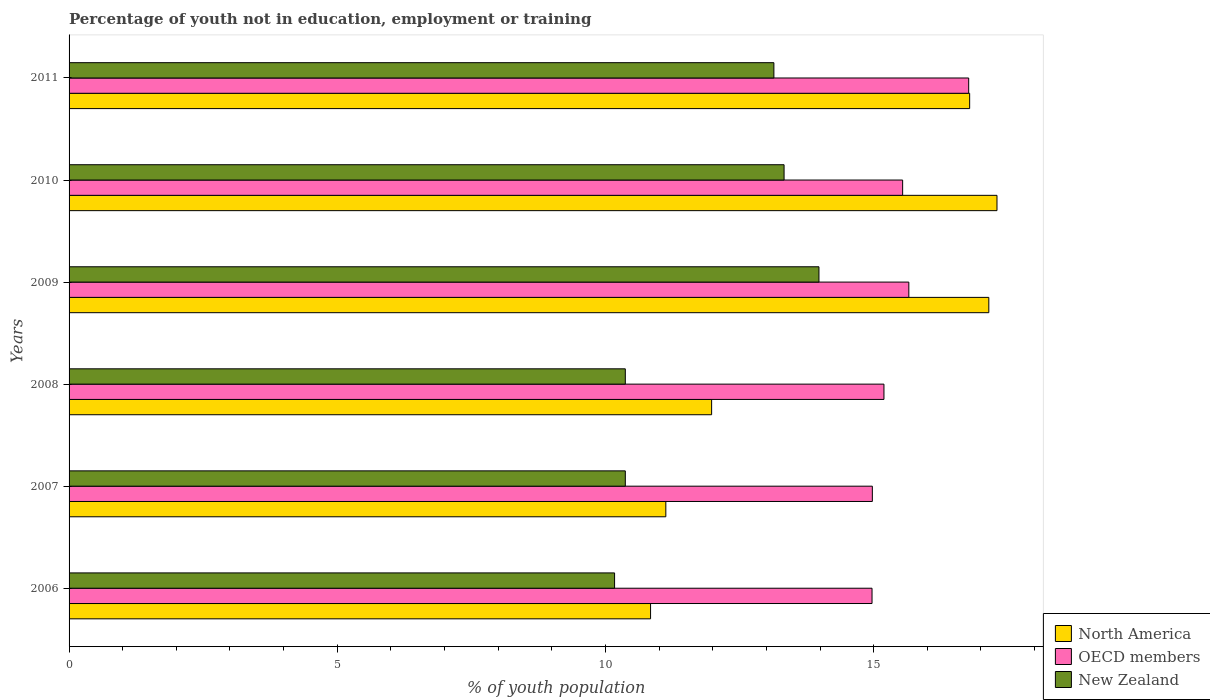How many groups of bars are there?
Give a very brief answer. 6. Are the number of bars on each tick of the Y-axis equal?
Provide a succinct answer. Yes. What is the label of the 2nd group of bars from the top?
Give a very brief answer. 2010. What is the percentage of unemployed youth population in in New Zealand in 2006?
Offer a very short reply. 10.17. Across all years, what is the maximum percentage of unemployed youth population in in North America?
Give a very brief answer. 17.3. Across all years, what is the minimum percentage of unemployed youth population in in New Zealand?
Ensure brevity in your answer.  10.17. What is the total percentage of unemployed youth population in in New Zealand in the graph?
Provide a short and direct response. 71.36. What is the difference between the percentage of unemployed youth population in in North America in 2010 and that in 2011?
Keep it short and to the point. 0.51. What is the difference between the percentage of unemployed youth population in in North America in 2009 and the percentage of unemployed youth population in in New Zealand in 2008?
Offer a terse response. 6.78. What is the average percentage of unemployed youth population in in North America per year?
Keep it short and to the point. 14.2. In the year 2008, what is the difference between the percentage of unemployed youth population in in OECD members and percentage of unemployed youth population in in North America?
Provide a succinct answer. 3.21. What is the ratio of the percentage of unemployed youth population in in OECD members in 2007 to that in 2010?
Your answer should be very brief. 0.96. Is the percentage of unemployed youth population in in OECD members in 2006 less than that in 2008?
Your answer should be very brief. Yes. Is the difference between the percentage of unemployed youth population in in OECD members in 2006 and 2010 greater than the difference between the percentage of unemployed youth population in in North America in 2006 and 2010?
Your answer should be very brief. Yes. What is the difference between the highest and the second highest percentage of unemployed youth population in in North America?
Make the answer very short. 0.15. What is the difference between the highest and the lowest percentage of unemployed youth population in in North America?
Ensure brevity in your answer.  6.46. Is the sum of the percentage of unemployed youth population in in New Zealand in 2006 and 2009 greater than the maximum percentage of unemployed youth population in in OECD members across all years?
Your response must be concise. Yes. What does the 1st bar from the top in 2006 represents?
Give a very brief answer. New Zealand. What does the 3rd bar from the bottom in 2008 represents?
Keep it short and to the point. New Zealand. Is it the case that in every year, the sum of the percentage of unemployed youth population in in North America and percentage of unemployed youth population in in OECD members is greater than the percentage of unemployed youth population in in New Zealand?
Provide a succinct answer. Yes. How many bars are there?
Make the answer very short. 18. How many years are there in the graph?
Your response must be concise. 6. Does the graph contain any zero values?
Your answer should be very brief. No. Where does the legend appear in the graph?
Keep it short and to the point. Bottom right. What is the title of the graph?
Provide a short and direct response. Percentage of youth not in education, employment or training. What is the label or title of the X-axis?
Your answer should be compact. % of youth population. What is the % of youth population in North America in 2006?
Ensure brevity in your answer.  10.84. What is the % of youth population in OECD members in 2006?
Give a very brief answer. 14.97. What is the % of youth population of New Zealand in 2006?
Offer a terse response. 10.17. What is the % of youth population in North America in 2007?
Provide a succinct answer. 11.13. What is the % of youth population in OECD members in 2007?
Your answer should be very brief. 14.98. What is the % of youth population in New Zealand in 2007?
Give a very brief answer. 10.37. What is the % of youth population in North America in 2008?
Provide a succinct answer. 11.98. What is the % of youth population of OECD members in 2008?
Your response must be concise. 15.19. What is the % of youth population in New Zealand in 2008?
Your response must be concise. 10.37. What is the % of youth population in North America in 2009?
Offer a very short reply. 17.15. What is the % of youth population of OECD members in 2009?
Your response must be concise. 15.66. What is the % of youth population in New Zealand in 2009?
Make the answer very short. 13.98. What is the % of youth population of North America in 2010?
Your response must be concise. 17.3. What is the % of youth population of OECD members in 2010?
Ensure brevity in your answer.  15.54. What is the % of youth population of New Zealand in 2010?
Give a very brief answer. 13.33. What is the % of youth population in North America in 2011?
Make the answer very short. 16.79. What is the % of youth population in OECD members in 2011?
Offer a terse response. 16.77. What is the % of youth population in New Zealand in 2011?
Offer a very short reply. 13.14. Across all years, what is the maximum % of youth population of North America?
Provide a short and direct response. 17.3. Across all years, what is the maximum % of youth population of OECD members?
Your answer should be compact. 16.77. Across all years, what is the maximum % of youth population of New Zealand?
Offer a terse response. 13.98. Across all years, what is the minimum % of youth population in North America?
Ensure brevity in your answer.  10.84. Across all years, what is the minimum % of youth population of OECD members?
Offer a very short reply. 14.97. Across all years, what is the minimum % of youth population in New Zealand?
Provide a succinct answer. 10.17. What is the total % of youth population of North America in the graph?
Make the answer very short. 85.18. What is the total % of youth population of OECD members in the graph?
Your answer should be compact. 93.1. What is the total % of youth population of New Zealand in the graph?
Give a very brief answer. 71.36. What is the difference between the % of youth population in North America in 2006 and that in 2007?
Your response must be concise. -0.28. What is the difference between the % of youth population of OECD members in 2006 and that in 2007?
Offer a terse response. -0.01. What is the difference between the % of youth population in North America in 2006 and that in 2008?
Your response must be concise. -1.14. What is the difference between the % of youth population in OECD members in 2006 and that in 2008?
Your response must be concise. -0.22. What is the difference between the % of youth population of New Zealand in 2006 and that in 2008?
Provide a short and direct response. -0.2. What is the difference between the % of youth population in North America in 2006 and that in 2009?
Make the answer very short. -6.31. What is the difference between the % of youth population in OECD members in 2006 and that in 2009?
Your answer should be very brief. -0.69. What is the difference between the % of youth population of New Zealand in 2006 and that in 2009?
Your answer should be very brief. -3.81. What is the difference between the % of youth population of North America in 2006 and that in 2010?
Offer a very short reply. -6.46. What is the difference between the % of youth population of OECD members in 2006 and that in 2010?
Provide a short and direct response. -0.57. What is the difference between the % of youth population of New Zealand in 2006 and that in 2010?
Provide a short and direct response. -3.16. What is the difference between the % of youth population of North America in 2006 and that in 2011?
Provide a short and direct response. -5.95. What is the difference between the % of youth population of OECD members in 2006 and that in 2011?
Your answer should be very brief. -1.8. What is the difference between the % of youth population in New Zealand in 2006 and that in 2011?
Your response must be concise. -2.97. What is the difference between the % of youth population in North America in 2007 and that in 2008?
Offer a terse response. -0.85. What is the difference between the % of youth population in OECD members in 2007 and that in 2008?
Provide a short and direct response. -0.22. What is the difference between the % of youth population of New Zealand in 2007 and that in 2008?
Your answer should be very brief. 0. What is the difference between the % of youth population in North America in 2007 and that in 2009?
Your answer should be very brief. -6.02. What is the difference between the % of youth population of OECD members in 2007 and that in 2009?
Offer a very short reply. -0.68. What is the difference between the % of youth population in New Zealand in 2007 and that in 2009?
Give a very brief answer. -3.61. What is the difference between the % of youth population of North America in 2007 and that in 2010?
Provide a succinct answer. -6.17. What is the difference between the % of youth population of OECD members in 2007 and that in 2010?
Make the answer very short. -0.56. What is the difference between the % of youth population of New Zealand in 2007 and that in 2010?
Provide a short and direct response. -2.96. What is the difference between the % of youth population of North America in 2007 and that in 2011?
Ensure brevity in your answer.  -5.66. What is the difference between the % of youth population in OECD members in 2007 and that in 2011?
Provide a short and direct response. -1.8. What is the difference between the % of youth population of New Zealand in 2007 and that in 2011?
Offer a very short reply. -2.77. What is the difference between the % of youth population of North America in 2008 and that in 2009?
Make the answer very short. -5.17. What is the difference between the % of youth population in OECD members in 2008 and that in 2009?
Make the answer very short. -0.46. What is the difference between the % of youth population of New Zealand in 2008 and that in 2009?
Provide a short and direct response. -3.61. What is the difference between the % of youth population of North America in 2008 and that in 2010?
Offer a very short reply. -5.32. What is the difference between the % of youth population of OECD members in 2008 and that in 2010?
Provide a short and direct response. -0.35. What is the difference between the % of youth population of New Zealand in 2008 and that in 2010?
Make the answer very short. -2.96. What is the difference between the % of youth population of North America in 2008 and that in 2011?
Keep it short and to the point. -4.81. What is the difference between the % of youth population in OECD members in 2008 and that in 2011?
Make the answer very short. -1.58. What is the difference between the % of youth population of New Zealand in 2008 and that in 2011?
Your answer should be compact. -2.77. What is the difference between the % of youth population of North America in 2009 and that in 2010?
Provide a short and direct response. -0.15. What is the difference between the % of youth population of OECD members in 2009 and that in 2010?
Make the answer very short. 0.12. What is the difference between the % of youth population in New Zealand in 2009 and that in 2010?
Your answer should be compact. 0.65. What is the difference between the % of youth population in North America in 2009 and that in 2011?
Provide a short and direct response. 0.36. What is the difference between the % of youth population in OECD members in 2009 and that in 2011?
Your answer should be very brief. -1.12. What is the difference between the % of youth population in New Zealand in 2009 and that in 2011?
Keep it short and to the point. 0.84. What is the difference between the % of youth population in North America in 2010 and that in 2011?
Ensure brevity in your answer.  0.51. What is the difference between the % of youth population in OECD members in 2010 and that in 2011?
Give a very brief answer. -1.23. What is the difference between the % of youth population of New Zealand in 2010 and that in 2011?
Provide a succinct answer. 0.19. What is the difference between the % of youth population of North America in 2006 and the % of youth population of OECD members in 2007?
Keep it short and to the point. -4.13. What is the difference between the % of youth population in North America in 2006 and the % of youth population in New Zealand in 2007?
Make the answer very short. 0.47. What is the difference between the % of youth population of OECD members in 2006 and the % of youth population of New Zealand in 2007?
Offer a very short reply. 4.6. What is the difference between the % of youth population of North America in 2006 and the % of youth population of OECD members in 2008?
Ensure brevity in your answer.  -4.35. What is the difference between the % of youth population in North America in 2006 and the % of youth population in New Zealand in 2008?
Ensure brevity in your answer.  0.47. What is the difference between the % of youth population in OECD members in 2006 and the % of youth population in New Zealand in 2008?
Your answer should be very brief. 4.6. What is the difference between the % of youth population in North America in 2006 and the % of youth population in OECD members in 2009?
Your response must be concise. -4.81. What is the difference between the % of youth population in North America in 2006 and the % of youth population in New Zealand in 2009?
Give a very brief answer. -3.14. What is the difference between the % of youth population of North America in 2006 and the % of youth population of OECD members in 2010?
Make the answer very short. -4.7. What is the difference between the % of youth population in North America in 2006 and the % of youth population in New Zealand in 2010?
Your answer should be very brief. -2.49. What is the difference between the % of youth population in OECD members in 2006 and the % of youth population in New Zealand in 2010?
Your response must be concise. 1.64. What is the difference between the % of youth population in North America in 2006 and the % of youth population in OECD members in 2011?
Keep it short and to the point. -5.93. What is the difference between the % of youth population in North America in 2006 and the % of youth population in New Zealand in 2011?
Make the answer very short. -2.3. What is the difference between the % of youth population in OECD members in 2006 and the % of youth population in New Zealand in 2011?
Provide a succinct answer. 1.83. What is the difference between the % of youth population in North America in 2007 and the % of youth population in OECD members in 2008?
Your answer should be compact. -4.07. What is the difference between the % of youth population of North America in 2007 and the % of youth population of New Zealand in 2008?
Your answer should be very brief. 0.76. What is the difference between the % of youth population of OECD members in 2007 and the % of youth population of New Zealand in 2008?
Your answer should be compact. 4.61. What is the difference between the % of youth population in North America in 2007 and the % of youth population in OECD members in 2009?
Give a very brief answer. -4.53. What is the difference between the % of youth population in North America in 2007 and the % of youth population in New Zealand in 2009?
Your response must be concise. -2.85. What is the difference between the % of youth population in North America in 2007 and the % of youth population in OECD members in 2010?
Keep it short and to the point. -4.42. What is the difference between the % of youth population in North America in 2007 and the % of youth population in New Zealand in 2010?
Offer a terse response. -2.2. What is the difference between the % of youth population in OECD members in 2007 and the % of youth population in New Zealand in 2010?
Offer a very short reply. 1.65. What is the difference between the % of youth population of North America in 2007 and the % of youth population of OECD members in 2011?
Keep it short and to the point. -5.65. What is the difference between the % of youth population of North America in 2007 and the % of youth population of New Zealand in 2011?
Make the answer very short. -2.01. What is the difference between the % of youth population of OECD members in 2007 and the % of youth population of New Zealand in 2011?
Your answer should be very brief. 1.84. What is the difference between the % of youth population of North America in 2008 and the % of youth population of OECD members in 2009?
Your response must be concise. -3.68. What is the difference between the % of youth population in North America in 2008 and the % of youth population in New Zealand in 2009?
Offer a very short reply. -2. What is the difference between the % of youth population in OECD members in 2008 and the % of youth population in New Zealand in 2009?
Give a very brief answer. 1.21. What is the difference between the % of youth population in North America in 2008 and the % of youth population in OECD members in 2010?
Your response must be concise. -3.56. What is the difference between the % of youth population in North America in 2008 and the % of youth population in New Zealand in 2010?
Provide a short and direct response. -1.35. What is the difference between the % of youth population in OECD members in 2008 and the % of youth population in New Zealand in 2010?
Offer a terse response. 1.86. What is the difference between the % of youth population in North America in 2008 and the % of youth population in OECD members in 2011?
Offer a terse response. -4.79. What is the difference between the % of youth population in North America in 2008 and the % of youth population in New Zealand in 2011?
Provide a succinct answer. -1.16. What is the difference between the % of youth population of OECD members in 2008 and the % of youth population of New Zealand in 2011?
Give a very brief answer. 2.05. What is the difference between the % of youth population of North America in 2009 and the % of youth population of OECD members in 2010?
Make the answer very short. 1.61. What is the difference between the % of youth population of North America in 2009 and the % of youth population of New Zealand in 2010?
Provide a short and direct response. 3.82. What is the difference between the % of youth population in OECD members in 2009 and the % of youth population in New Zealand in 2010?
Your answer should be compact. 2.33. What is the difference between the % of youth population of North America in 2009 and the % of youth population of OECD members in 2011?
Give a very brief answer. 0.38. What is the difference between the % of youth population in North America in 2009 and the % of youth population in New Zealand in 2011?
Provide a succinct answer. 4.01. What is the difference between the % of youth population in OECD members in 2009 and the % of youth population in New Zealand in 2011?
Provide a succinct answer. 2.52. What is the difference between the % of youth population in North America in 2010 and the % of youth population in OECD members in 2011?
Provide a succinct answer. 0.53. What is the difference between the % of youth population of North America in 2010 and the % of youth population of New Zealand in 2011?
Your response must be concise. 4.16. What is the difference between the % of youth population in OECD members in 2010 and the % of youth population in New Zealand in 2011?
Make the answer very short. 2.4. What is the average % of youth population of North America per year?
Offer a terse response. 14.2. What is the average % of youth population in OECD members per year?
Provide a short and direct response. 15.52. What is the average % of youth population of New Zealand per year?
Make the answer very short. 11.89. In the year 2006, what is the difference between the % of youth population of North America and % of youth population of OECD members?
Provide a succinct answer. -4.13. In the year 2006, what is the difference between the % of youth population of North America and % of youth population of New Zealand?
Offer a very short reply. 0.67. In the year 2006, what is the difference between the % of youth population of OECD members and % of youth population of New Zealand?
Offer a terse response. 4.8. In the year 2007, what is the difference between the % of youth population of North America and % of youth population of OECD members?
Your answer should be very brief. -3.85. In the year 2007, what is the difference between the % of youth population in North America and % of youth population in New Zealand?
Make the answer very short. 0.76. In the year 2007, what is the difference between the % of youth population in OECD members and % of youth population in New Zealand?
Give a very brief answer. 4.61. In the year 2008, what is the difference between the % of youth population in North America and % of youth population in OECD members?
Your answer should be compact. -3.21. In the year 2008, what is the difference between the % of youth population in North America and % of youth population in New Zealand?
Provide a short and direct response. 1.61. In the year 2008, what is the difference between the % of youth population of OECD members and % of youth population of New Zealand?
Provide a short and direct response. 4.82. In the year 2009, what is the difference between the % of youth population of North America and % of youth population of OECD members?
Offer a very short reply. 1.49. In the year 2009, what is the difference between the % of youth population of North America and % of youth population of New Zealand?
Ensure brevity in your answer.  3.17. In the year 2009, what is the difference between the % of youth population in OECD members and % of youth population in New Zealand?
Ensure brevity in your answer.  1.68. In the year 2010, what is the difference between the % of youth population of North America and % of youth population of OECD members?
Offer a very short reply. 1.76. In the year 2010, what is the difference between the % of youth population in North America and % of youth population in New Zealand?
Keep it short and to the point. 3.97. In the year 2010, what is the difference between the % of youth population in OECD members and % of youth population in New Zealand?
Ensure brevity in your answer.  2.21. In the year 2011, what is the difference between the % of youth population in North America and % of youth population in OECD members?
Provide a short and direct response. 0.02. In the year 2011, what is the difference between the % of youth population in North America and % of youth population in New Zealand?
Provide a succinct answer. 3.65. In the year 2011, what is the difference between the % of youth population of OECD members and % of youth population of New Zealand?
Your response must be concise. 3.63. What is the ratio of the % of youth population of North America in 2006 to that in 2007?
Make the answer very short. 0.97. What is the ratio of the % of youth population of New Zealand in 2006 to that in 2007?
Provide a succinct answer. 0.98. What is the ratio of the % of youth population in North America in 2006 to that in 2008?
Offer a terse response. 0.91. What is the ratio of the % of youth population of OECD members in 2006 to that in 2008?
Offer a very short reply. 0.99. What is the ratio of the % of youth population in New Zealand in 2006 to that in 2008?
Provide a short and direct response. 0.98. What is the ratio of the % of youth population in North America in 2006 to that in 2009?
Provide a short and direct response. 0.63. What is the ratio of the % of youth population in OECD members in 2006 to that in 2009?
Your answer should be very brief. 0.96. What is the ratio of the % of youth population of New Zealand in 2006 to that in 2009?
Ensure brevity in your answer.  0.73. What is the ratio of the % of youth population of North America in 2006 to that in 2010?
Keep it short and to the point. 0.63. What is the ratio of the % of youth population in OECD members in 2006 to that in 2010?
Provide a succinct answer. 0.96. What is the ratio of the % of youth population in New Zealand in 2006 to that in 2010?
Offer a very short reply. 0.76. What is the ratio of the % of youth population in North America in 2006 to that in 2011?
Make the answer very short. 0.65. What is the ratio of the % of youth population of OECD members in 2006 to that in 2011?
Your answer should be compact. 0.89. What is the ratio of the % of youth population in New Zealand in 2006 to that in 2011?
Your response must be concise. 0.77. What is the ratio of the % of youth population in North America in 2007 to that in 2008?
Offer a terse response. 0.93. What is the ratio of the % of youth population of OECD members in 2007 to that in 2008?
Your answer should be compact. 0.99. What is the ratio of the % of youth population in New Zealand in 2007 to that in 2008?
Keep it short and to the point. 1. What is the ratio of the % of youth population in North America in 2007 to that in 2009?
Ensure brevity in your answer.  0.65. What is the ratio of the % of youth population in OECD members in 2007 to that in 2009?
Your answer should be compact. 0.96. What is the ratio of the % of youth population in New Zealand in 2007 to that in 2009?
Provide a succinct answer. 0.74. What is the ratio of the % of youth population in North America in 2007 to that in 2010?
Your answer should be compact. 0.64. What is the ratio of the % of youth population in OECD members in 2007 to that in 2010?
Offer a very short reply. 0.96. What is the ratio of the % of youth population of New Zealand in 2007 to that in 2010?
Your answer should be compact. 0.78. What is the ratio of the % of youth population of North America in 2007 to that in 2011?
Provide a succinct answer. 0.66. What is the ratio of the % of youth population of OECD members in 2007 to that in 2011?
Make the answer very short. 0.89. What is the ratio of the % of youth population of New Zealand in 2007 to that in 2011?
Offer a very short reply. 0.79. What is the ratio of the % of youth population of North America in 2008 to that in 2009?
Give a very brief answer. 0.7. What is the ratio of the % of youth population of OECD members in 2008 to that in 2009?
Provide a short and direct response. 0.97. What is the ratio of the % of youth population in New Zealand in 2008 to that in 2009?
Offer a terse response. 0.74. What is the ratio of the % of youth population of North America in 2008 to that in 2010?
Make the answer very short. 0.69. What is the ratio of the % of youth population of OECD members in 2008 to that in 2010?
Offer a very short reply. 0.98. What is the ratio of the % of youth population in New Zealand in 2008 to that in 2010?
Your response must be concise. 0.78. What is the ratio of the % of youth population in North America in 2008 to that in 2011?
Your answer should be very brief. 0.71. What is the ratio of the % of youth population in OECD members in 2008 to that in 2011?
Your response must be concise. 0.91. What is the ratio of the % of youth population of New Zealand in 2008 to that in 2011?
Provide a short and direct response. 0.79. What is the ratio of the % of youth population of OECD members in 2009 to that in 2010?
Offer a very short reply. 1.01. What is the ratio of the % of youth population of New Zealand in 2009 to that in 2010?
Provide a short and direct response. 1.05. What is the ratio of the % of youth population in North America in 2009 to that in 2011?
Provide a succinct answer. 1.02. What is the ratio of the % of youth population of OECD members in 2009 to that in 2011?
Your answer should be compact. 0.93. What is the ratio of the % of youth population of New Zealand in 2009 to that in 2011?
Offer a very short reply. 1.06. What is the ratio of the % of youth population of North America in 2010 to that in 2011?
Offer a very short reply. 1.03. What is the ratio of the % of youth population of OECD members in 2010 to that in 2011?
Provide a short and direct response. 0.93. What is the ratio of the % of youth population of New Zealand in 2010 to that in 2011?
Offer a terse response. 1.01. What is the difference between the highest and the second highest % of youth population in North America?
Your answer should be very brief. 0.15. What is the difference between the highest and the second highest % of youth population of OECD members?
Ensure brevity in your answer.  1.12. What is the difference between the highest and the second highest % of youth population in New Zealand?
Your answer should be compact. 0.65. What is the difference between the highest and the lowest % of youth population of North America?
Your answer should be compact. 6.46. What is the difference between the highest and the lowest % of youth population in OECD members?
Make the answer very short. 1.8. What is the difference between the highest and the lowest % of youth population of New Zealand?
Your answer should be very brief. 3.81. 